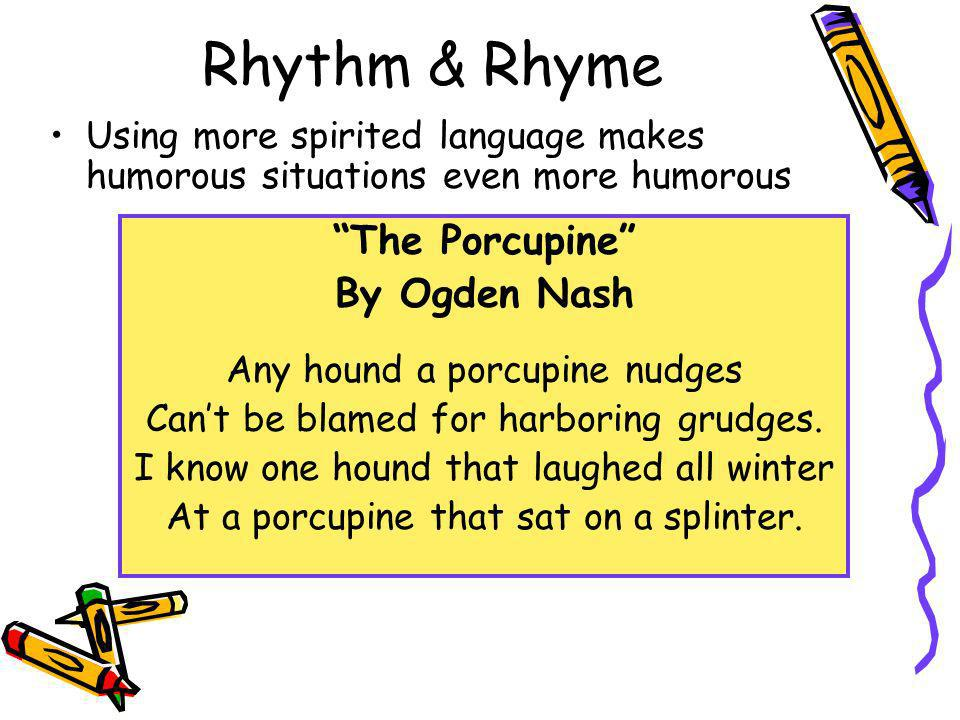How might the use of color and visual elements in this presentation slide enhance the humor in Ogden Nash's poem? The bright yellow background and playful crayon-like font in the slide contribute to an engaging, light-hearted visual appeal that aligns well with Nash's humorous style. The use of a comically large pencil graphic, curled paper corners, and the informal arrangement of text all serve to visually reinforce the whimsical, carefree nature of the poem, making the humorous content more accessible and enjoyable to the audience. 